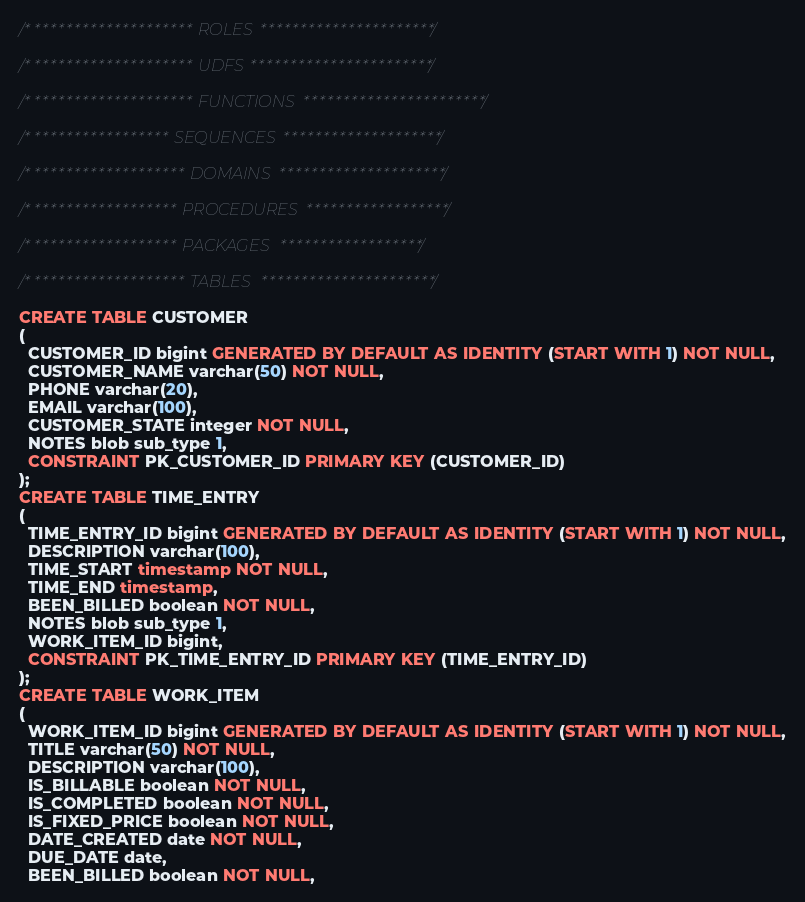Convert code to text. <code><loc_0><loc_0><loc_500><loc_500><_SQL_>/********************* ROLES **********************/

/********************* UDFS ***********************/

/********************* FUNCTIONS ***********************/

/****************** SEQUENCES ********************/

/******************** DOMAINS *********************/

/******************* PROCEDURES ******************/

/******************* PACKAGES ******************/

/******************** TABLES **********************/

CREATE TABLE CUSTOMER
(
  CUSTOMER_ID bigint GENERATED BY DEFAULT AS IDENTITY (START WITH 1) NOT NULL,
  CUSTOMER_NAME varchar(50) NOT NULL,
  PHONE varchar(20),
  EMAIL varchar(100),
  CUSTOMER_STATE integer NOT NULL,
  NOTES blob sub_type 1,
  CONSTRAINT PK_CUSTOMER_ID PRIMARY KEY (CUSTOMER_ID)
);
CREATE TABLE TIME_ENTRY
(
  TIME_ENTRY_ID bigint GENERATED BY DEFAULT AS IDENTITY (START WITH 1) NOT NULL,
  DESCRIPTION varchar(100),
  TIME_START timestamp NOT NULL,
  TIME_END timestamp,
  BEEN_BILLED boolean NOT NULL,
  NOTES blob sub_type 1,
  WORK_ITEM_ID bigint,
  CONSTRAINT PK_TIME_ENTRY_ID PRIMARY KEY (TIME_ENTRY_ID)
);
CREATE TABLE WORK_ITEM
(
  WORK_ITEM_ID bigint GENERATED BY DEFAULT AS IDENTITY (START WITH 1) NOT NULL,
  TITLE varchar(50) NOT NULL,
  DESCRIPTION varchar(100),
  IS_BILLABLE boolean NOT NULL,
  IS_COMPLETED boolean NOT NULL,
  IS_FIXED_PRICE boolean NOT NULL,
  DATE_CREATED date NOT NULL,
  DUE_DATE date,
  BEEN_BILLED boolean NOT NULL,</code> 